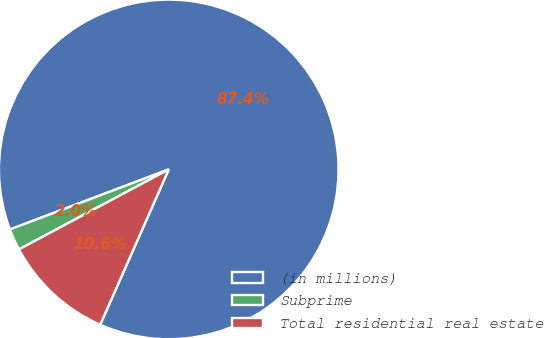Convert chart to OTSL. <chart><loc_0><loc_0><loc_500><loc_500><pie_chart><fcel>(in millions)<fcel>Subprime<fcel>Total residential real estate<nl><fcel>87.38%<fcel>2.05%<fcel>10.58%<nl></chart> 